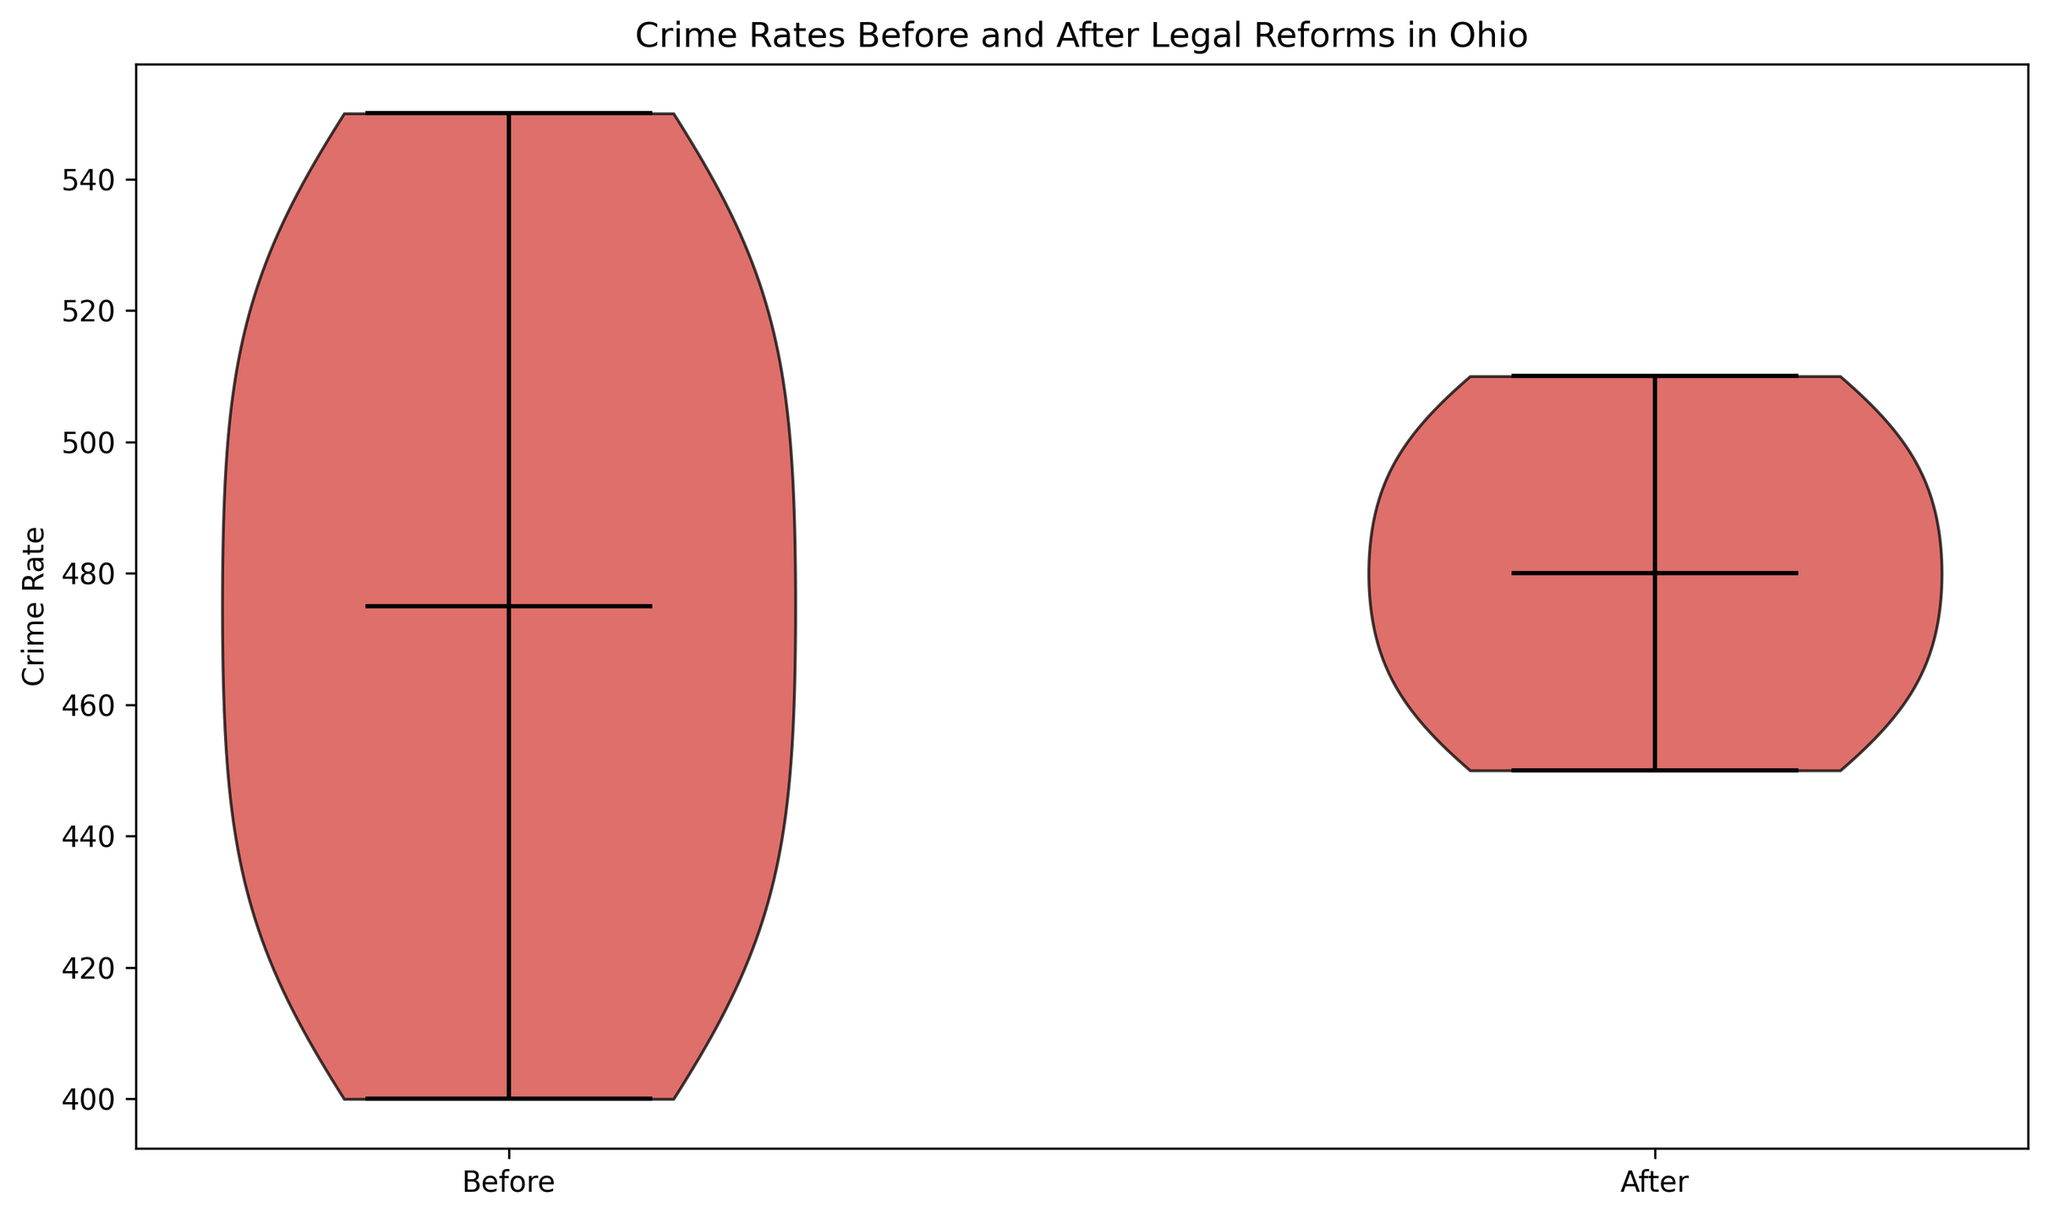What is the median crime rate before legal reforms? The violin plot shows the median values with a horizontal line inside the violin. Looking at the "Before" period, the median value can be found at the level where this line is shown.
Answer: 470 How does the median crime rate compare between the 'Before' and 'After' periods? To compare the median values, we look at the position of the horizontal line representing the median in each of the violins. The "Before" period's median is 470, while the "After" period's median is 480, indicating that the median crime rate increased after the reforms.
Answer: The 'After' period’s median is higher Is the interquartile range (IQR) wider for the crime rates before or after the legal reforms? The IQR can be visually estimated by looking at the thickness of the violin plots. A thicker middle section means a wider IQR. Comparing the "Before" and "After" distributions, the thicker middle section indicates that the IQR is wider before the reforms.
Answer: Wider before reforms Do both periods show any outliers in the crime rates, and if so, which period and where? To identify outliers, we need to look at any points outside the whiskers of the violin plots. The presence of such points indicates outliers. Here, there are no points outside the whiskers for either period, indicating no outliers.
Answer: No outliers Which period shows more variability in crime rates? Variability can be assessed by looking at the spread (width) of the violin plots. The wider and more spread out the violin plot is, the higher the variability. "Before" legal reforms have a more spread-out distribution, indicating more variability.
Answer: More variability before reforms Does any period show overlap between the minimum and maximum crime rates? We look at the bottom and top of the violin plots to see if the ranges overlap. The minimum and maximum values in the "Before" period overlap with those in the "After" period, meaning that crime rates overlap in terms of their minimums and maximums in both periods.
Answer: Yes, there is overlap How do the shapes of the violin plots compare between the two periods in terms of symmetry? Symmetry can be visualized by looking at each side of the violin plot. If the shape is even on both sides, it indicates symmetry. The "Before" period's violin plot is relatively symmetric, whereas the "After" period's plot seems less symmetric with a bulge towards the middle, indicating a slight skew.
Answer: The 'Before' period is more symmetric What is the most noticeable difference between the two distributions in the violin plot? The most noticeable difference is the shift in the median line. The "After" period shows a higher median compared to the "Before" period, which suggests an increase in the central tendency of crime rates after the legal reforms.
Answer: Higher median after reforms 